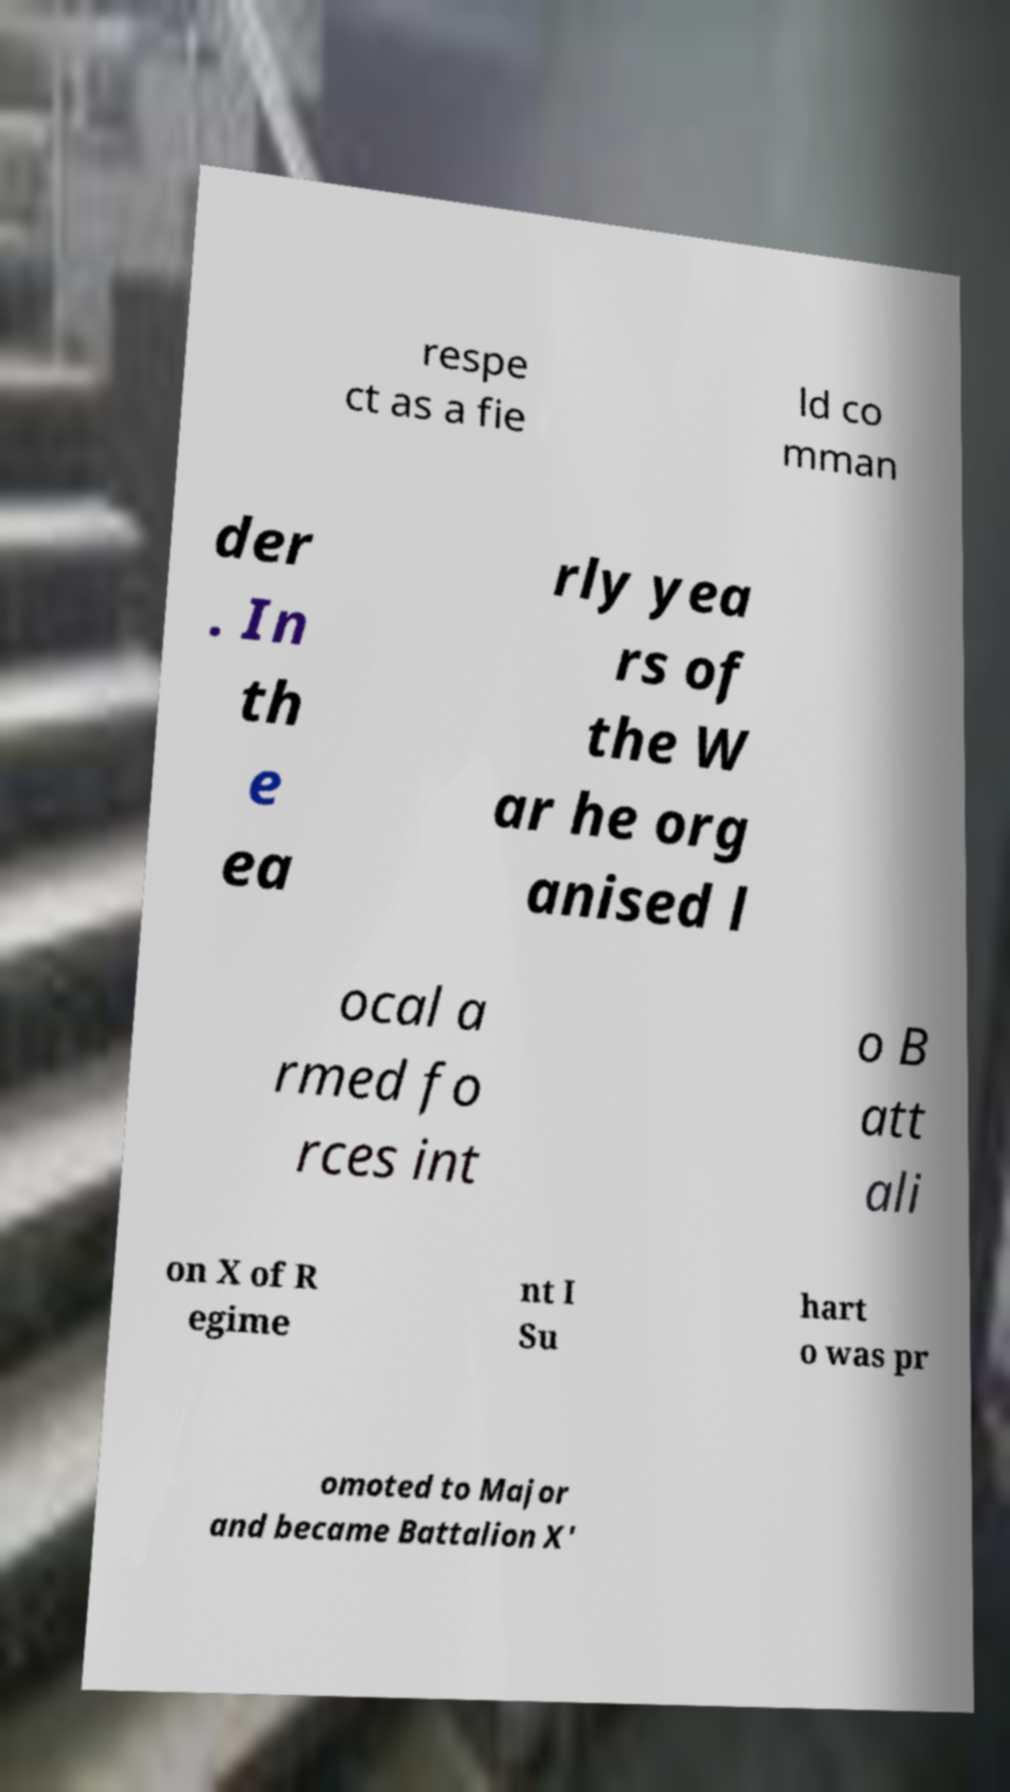There's text embedded in this image that I need extracted. Can you transcribe it verbatim? respe ct as a fie ld co mman der . In th e ea rly yea rs of the W ar he org anised l ocal a rmed fo rces int o B att ali on X of R egime nt I Su hart o was pr omoted to Major and became Battalion X' 